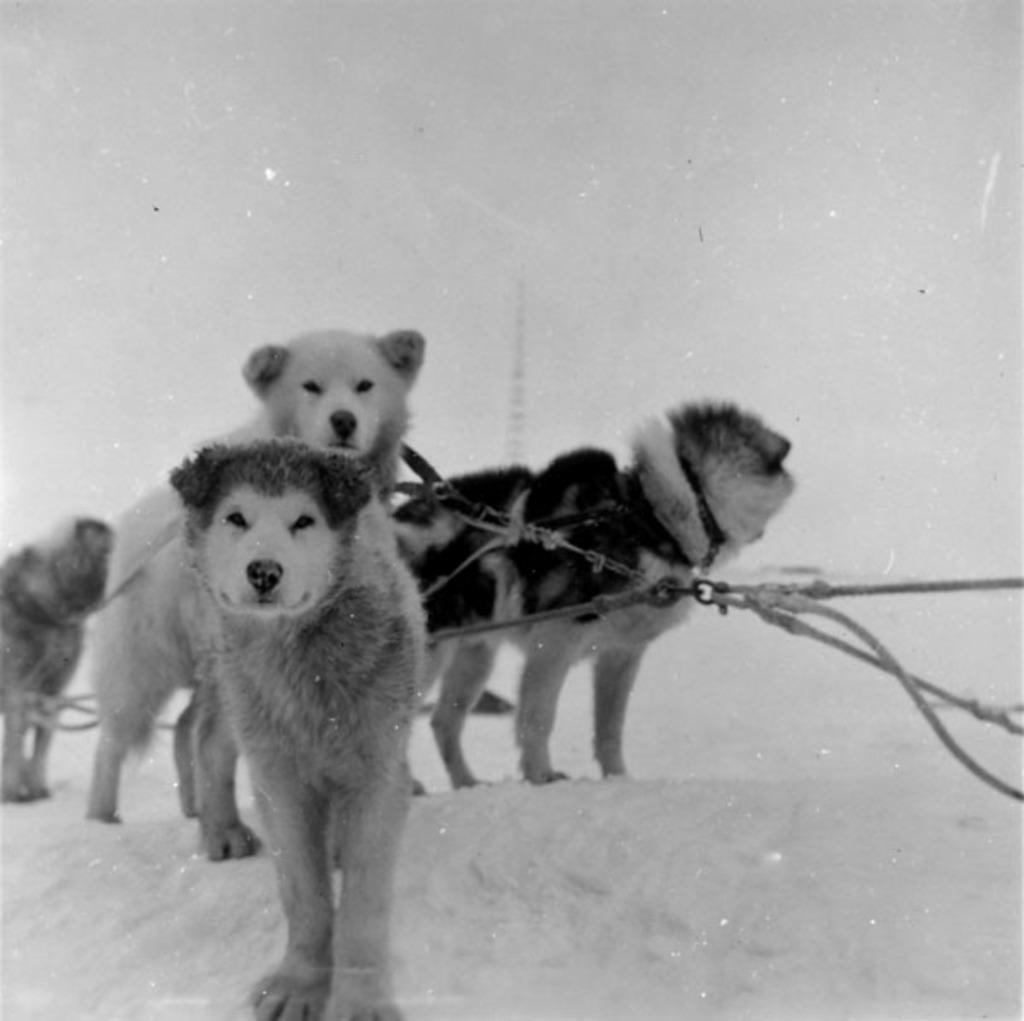Describe this image in one or two sentences. In this picture I can observe dogs on the snow. This is a black and white image. In the background there is a sky. 